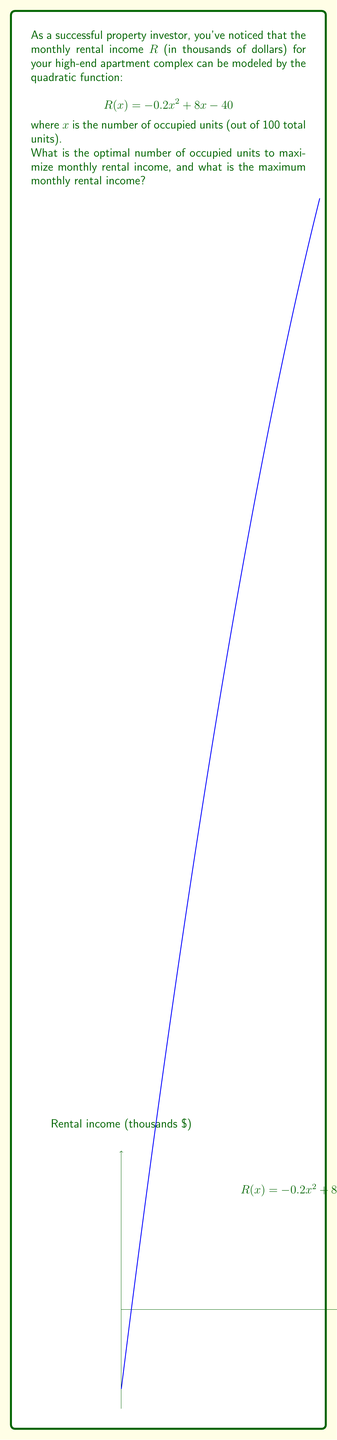Solve this math problem. To find the optimal number of occupied units and the maximum monthly rental income, we need to follow these steps:

1) The quadratic function is in the form $R(x) = -0.2x^2 + 8x - 40$, which is a parabola that opens downward (since the coefficient of $x^2$ is negative).

2) To find the vertex of this parabola (which represents the maximum point), we can use the formula $x = -\frac{b}{2a}$, where $a$ and $b$ are the coefficients of $x^2$ and $x$ respectively.

3) Calculating the x-coordinate of the vertex:
   $x = -\frac{8}{2(-0.2)} = -\frac{8}{-0.4} = 20$

4) To find the maximum rental income, we substitute this x-value back into the original function:
   $R(20) = -0.2(20)^2 + 8(20) - 40$
          $= -0.2(400) + 160 - 40$
          $= -80 + 160 - 40$
          $= 40$

5) Therefore, the maximum monthly rental income is $40,000 when 20 units are occupied.

6) To verify this is indeed a maximum (not a minimum), we can check the second derivative:
   $R'(x) = -0.4x + 8$
   $R''(x) = -0.4$
   Since $R''(x)$ is negative, this confirms we have found a maximum.
Answer: 20 units; $40,000 